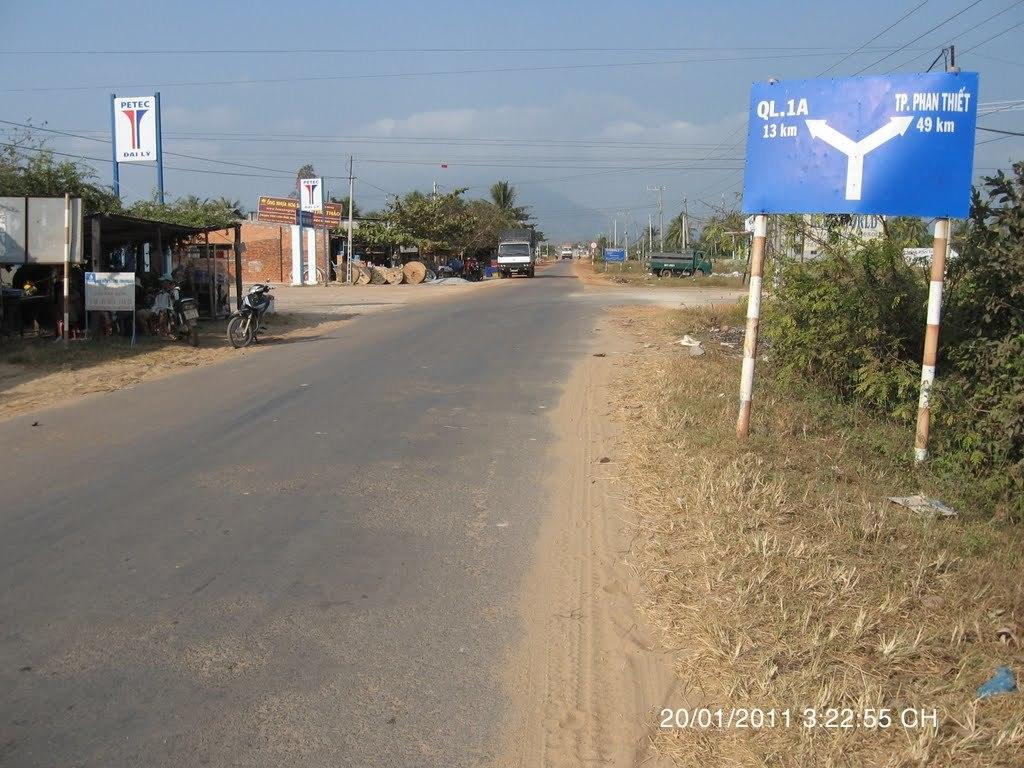Provide a one-sentence caption for the provided image. The picture of the road was taken on January 1st, 2011. 